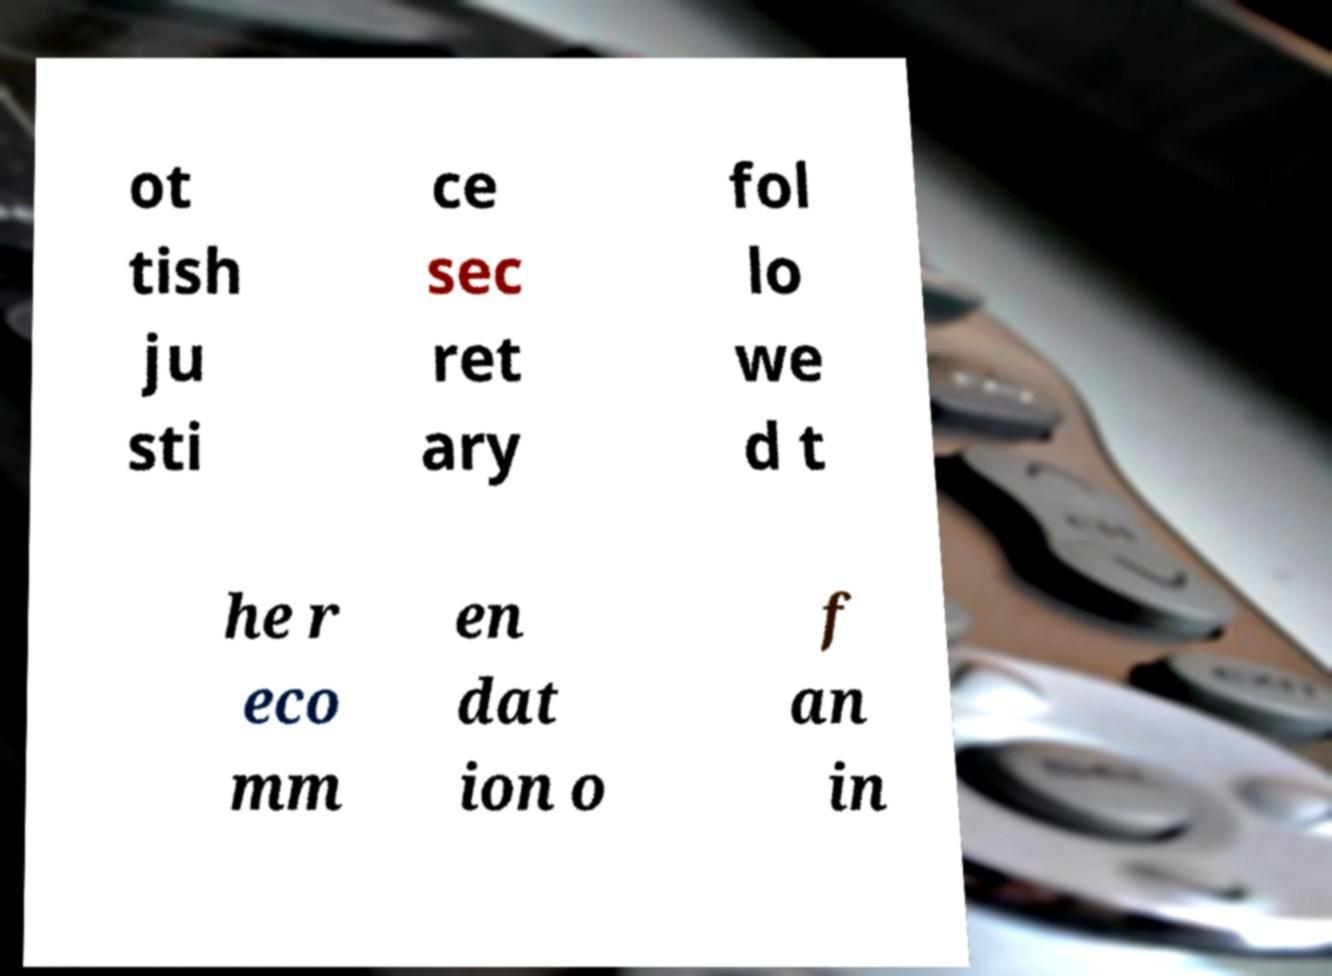Could you extract and type out the text from this image? ot tish ju sti ce sec ret ary fol lo we d t he r eco mm en dat ion o f an in 